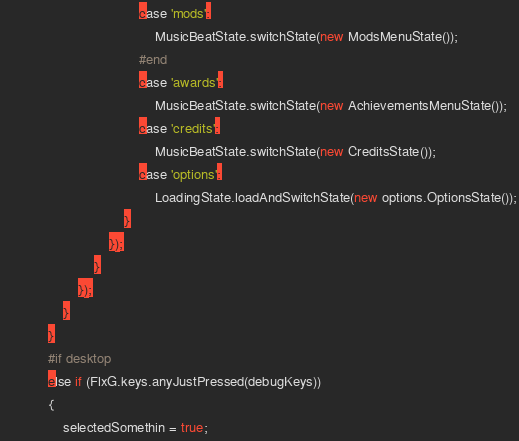<code> <loc_0><loc_0><loc_500><loc_500><_Haxe_>									case 'mods':
										MusicBeatState.switchState(new ModsMenuState());
									#end
									case 'awards':
										MusicBeatState.switchState(new AchievementsMenuState());
									case 'credits':
										MusicBeatState.switchState(new CreditsState());
									case 'options':
										LoadingState.loadAndSwitchState(new options.OptionsState());
								}
							});
						}
					});
				}
			}
			#if desktop
			else if (FlxG.keys.anyJustPressed(debugKeys))
			{
				selectedSomethin = true;</code> 